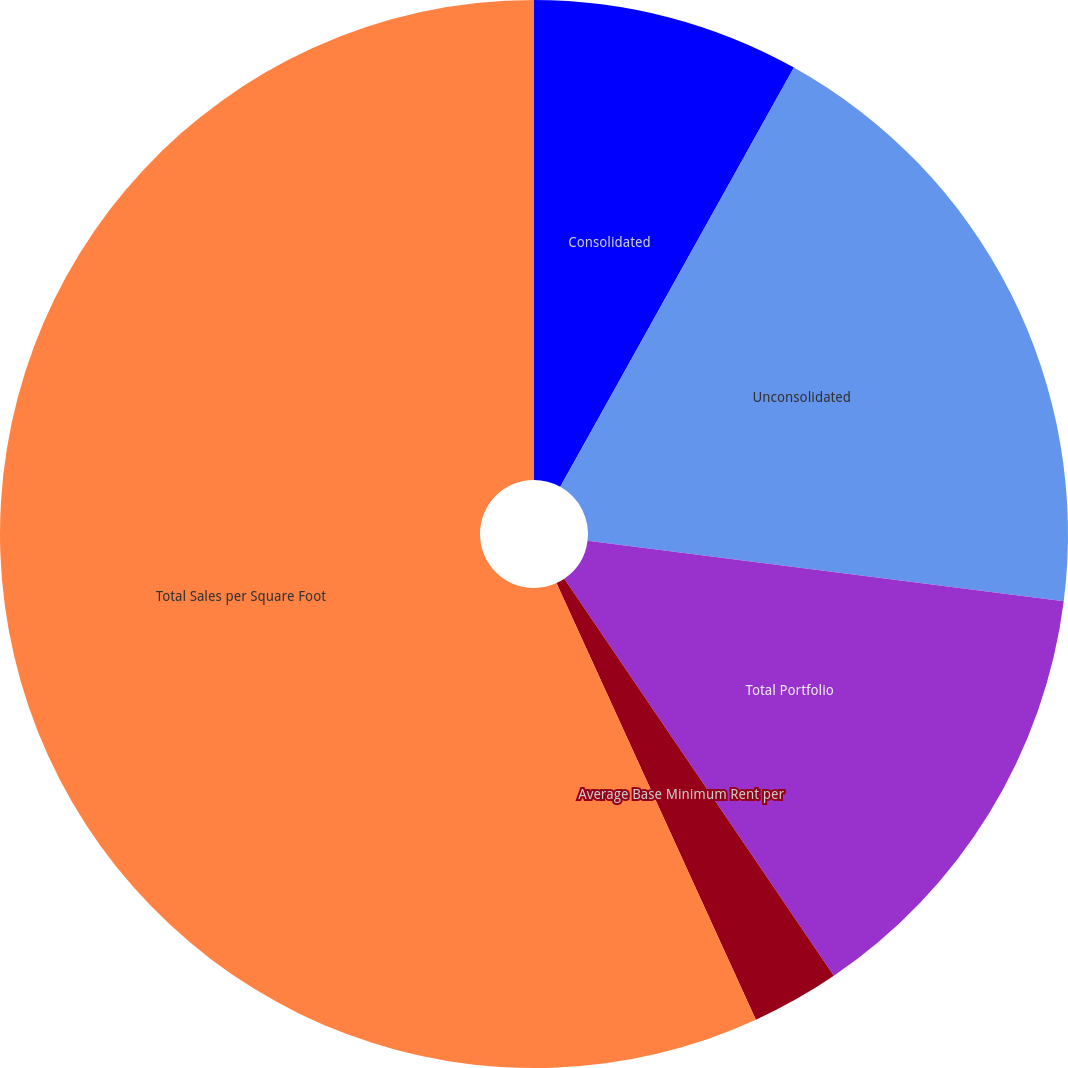Convert chart. <chart><loc_0><loc_0><loc_500><loc_500><pie_chart><fcel>Consolidated<fcel>Unconsolidated<fcel>Total Portfolio<fcel>Average Base Minimum Rent per<fcel>Total Sales per Square Foot<nl><fcel>8.09%<fcel>18.92%<fcel>13.5%<fcel>2.67%<fcel>56.82%<nl></chart> 